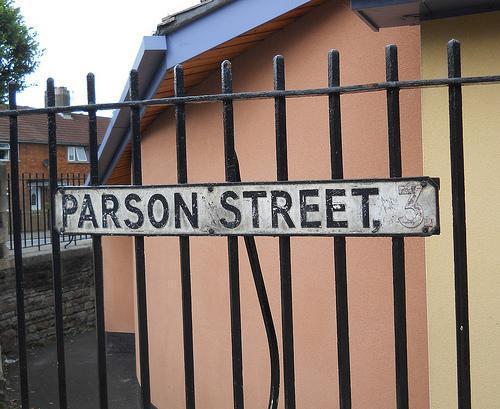How many street signs are there?
Give a very brief answer. 1. 